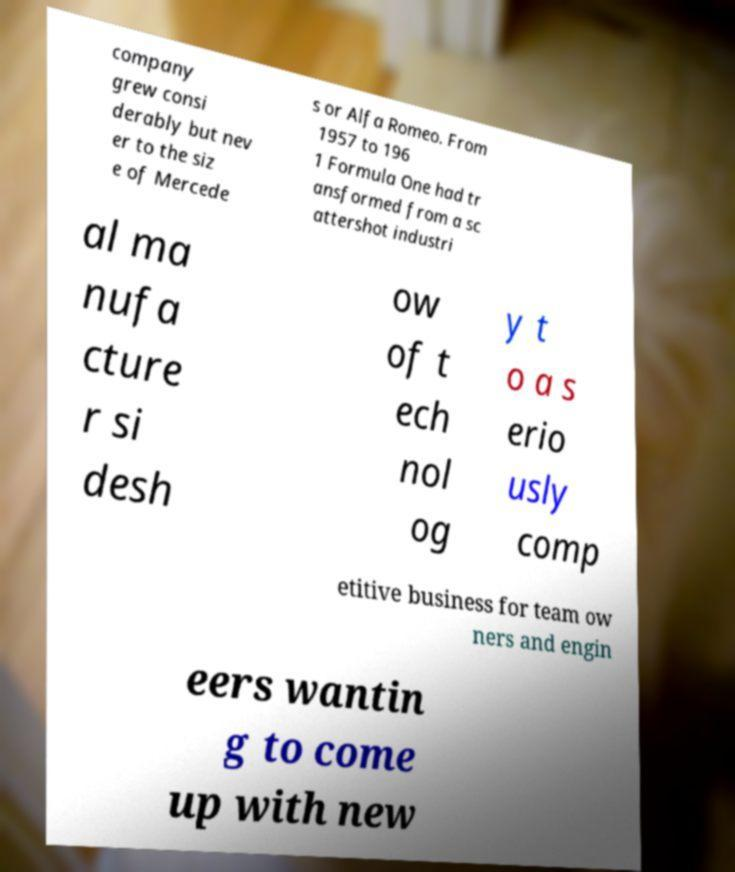Please read and relay the text visible in this image. What does it say? company grew consi derably but nev er to the siz e of Mercede s or Alfa Romeo. From 1957 to 196 1 Formula One had tr ansformed from a sc attershot industri al ma nufa cture r si desh ow of t ech nol og y t o a s erio usly comp etitive business for team ow ners and engin eers wantin g to come up with new 